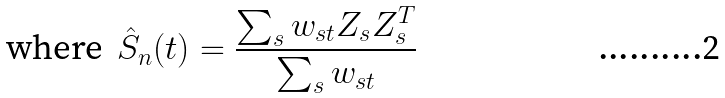Convert formula to latex. <formula><loc_0><loc_0><loc_500><loc_500>\text {where } \, \hat { S } _ { n } ( t ) = \frac { \sum _ { s } w _ { s t } Z _ { s } Z _ { s } ^ { T } } { \sum _ { s } w _ { s t } }</formula> 